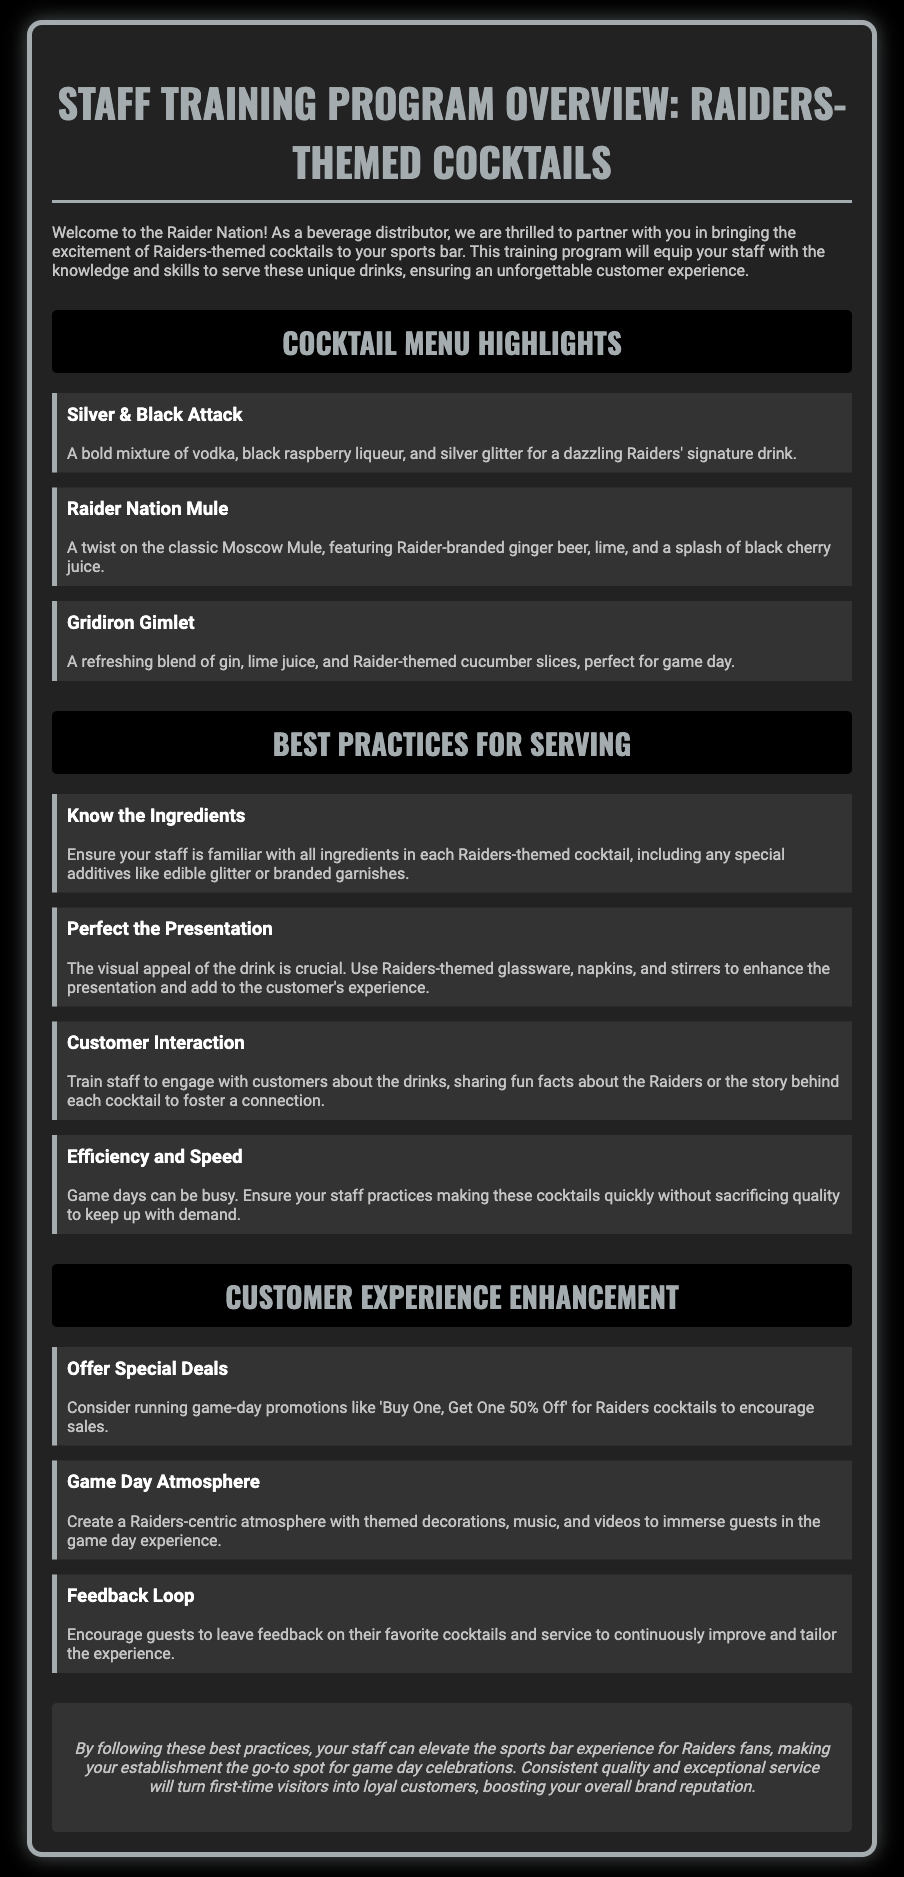what is the title of the training program? The title of the training program is highlighted at the top of the document.
Answer: Staff Training Program Overview: Raiders-Themed Cocktails how many cocktails are highlighted in the menu? The document lists three specific cocktails under the cocktail menu highlights.
Answer: Three what is the main ingredient in the "Silver & Black Attack"? The main ingredients of the cocktail are detailed in the description.
Answer: Vodka what is a recommended practice for customer interaction? The document outlines several best practices for serving cocktails, including this particular interaction tip.
Answer: Engage with customers what special deal is suggested for game day promotions? The suggestions for promotions are explicitly stated in the document.
Answer: Buy One, Get One 50% Off which cocktail features ginger beer? The cocktail descriptions specify which drink includes this ingredient.
Answer: Raider Nation Mule what aspect enhances the presentation of the cocktails? The document emphasizes the importance of certain elements in presentation.
Answer: Raiders-themed glassware what is the purpose of the training program? The opening paragraph describes the goal of the training program clearly.
Answer: Enhance customer experience 